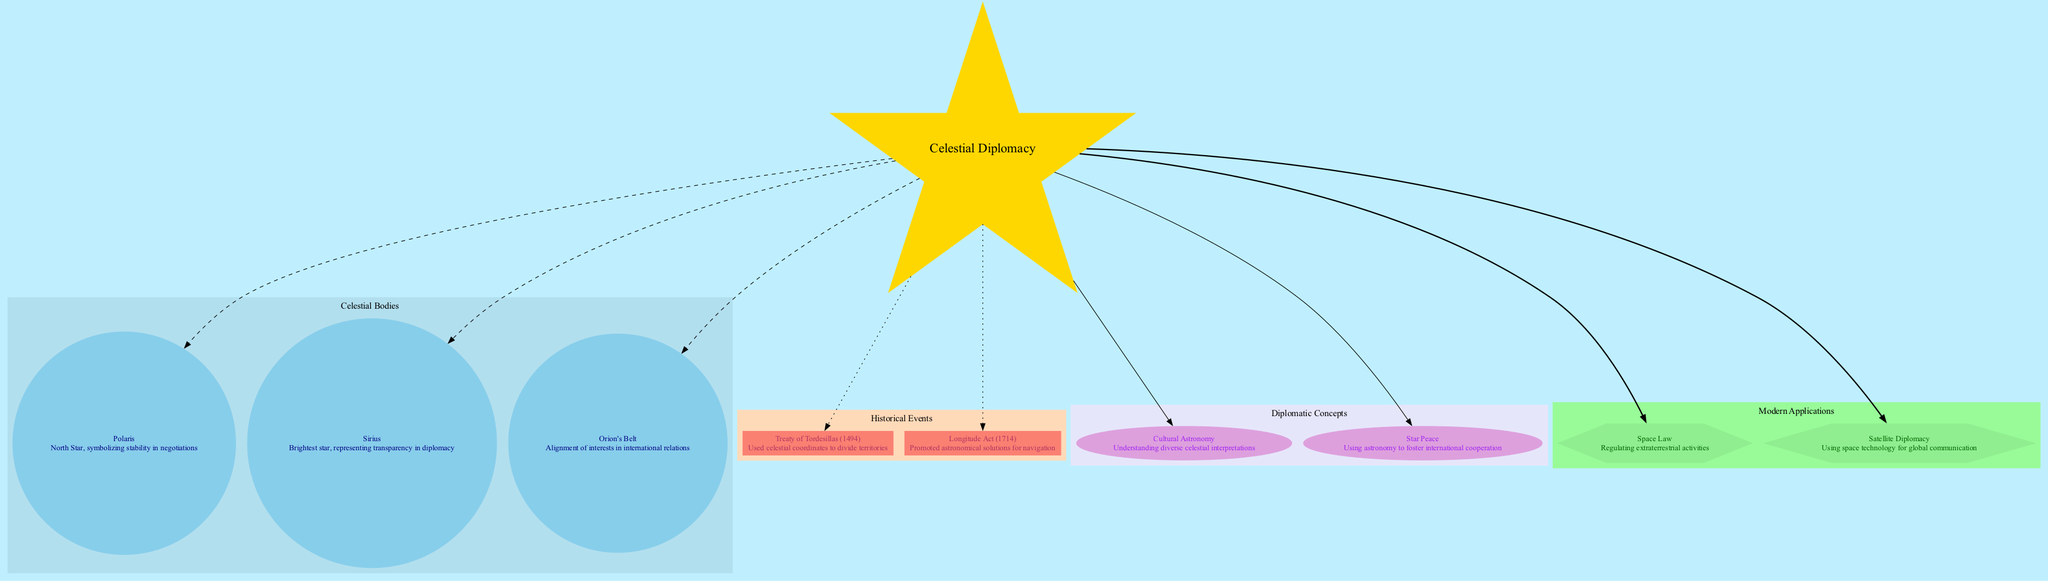What is the central concept depicted in the diagram? The diagram features "Celestial Diplomacy" as the central concept, which can be identified as it is the primary node marked in a star shape.
Answer: Celestial Diplomacy How many celestial bodies are represented in the diagram? The diagram includes three celestial bodies: Polaris, Sirius, and Orion's Belt. By counting the nodes in the "Celestial Bodies" cluster, the number of bodies can be easily determined.
Answer: 3 What does Polaris symbolize in celestial diplomacy? Polaris is labeled with the significance of "North Star, symbolizing stability in negotiations." This information is directly visible under the Polaris node.
Answer: Stability in negotiations Which historical event is connected to celestial coordinates? The "Treaty of Tordesillas (1494)" is connected to celestial coordinates as indicated in its respective node. The connection is explicitly stated in the node's description.
Answer: Treaty of Tordesillas What type of concepts are represented in the diplomatic concepts section? The diplomatic concepts section includes "Cultural Astronomy" and "Star Peace." These are labeled accordingly in the diagram with descriptions that clarify their significance, further confirming their nature as concepts.
Answer: Cultural Astronomy, Star Peace How does Orion's Belt relate to international relations? Orion's Belt is described as representing the "Alignment of interests in international relations." This information can be found beneath the Orion's Belt node, making its connection clear.
Answer: Alignment of interests What modern application is related to regulating extraterrestrial activities? The diagram lists "Space Law" as related to regulating extraterrestrial activities, which can be verified by reviewing the node in the "Modern Applications" section.
Answer: Space Law Which astronomical body represents transparency in diplomacy? Sirius is referred to as the "Brightest star, representing transparency in diplomacy" in its respective node. This significance directly answers the question about the body associated with transparency.
Answer: Sirius How many historical events are depicted in the diagram? There are two historical events represented in the diagram: Treaty of Tordesillas and Longitude Act. By looking at the nodes in the "Historical Events" section, we can easily count them.
Answer: 2 